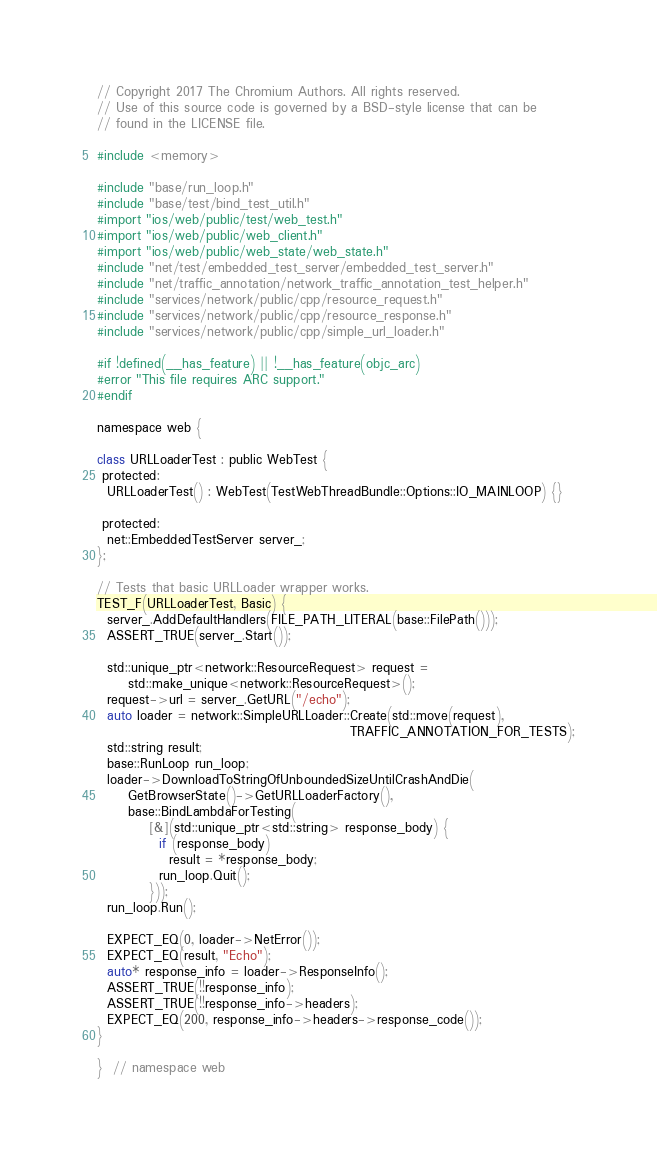<code> <loc_0><loc_0><loc_500><loc_500><_ObjectiveC_>// Copyright 2017 The Chromium Authors. All rights reserved.
// Use of this source code is governed by a BSD-style license that can be
// found in the LICENSE file.

#include <memory>

#include "base/run_loop.h"
#include "base/test/bind_test_util.h"
#import "ios/web/public/test/web_test.h"
#import "ios/web/public/web_client.h"
#import "ios/web/public/web_state/web_state.h"
#include "net/test/embedded_test_server/embedded_test_server.h"
#include "net/traffic_annotation/network_traffic_annotation_test_helper.h"
#include "services/network/public/cpp/resource_request.h"
#include "services/network/public/cpp/resource_response.h"
#include "services/network/public/cpp/simple_url_loader.h"

#if !defined(__has_feature) || !__has_feature(objc_arc)
#error "This file requires ARC support."
#endif

namespace web {

class URLLoaderTest : public WebTest {
 protected:
  URLLoaderTest() : WebTest(TestWebThreadBundle::Options::IO_MAINLOOP) {}

 protected:
  net::EmbeddedTestServer server_;
};

// Tests that basic URLLoader wrapper works.
TEST_F(URLLoaderTest, Basic) {
  server_.AddDefaultHandlers(FILE_PATH_LITERAL(base::FilePath()));
  ASSERT_TRUE(server_.Start());

  std::unique_ptr<network::ResourceRequest> request =
      std::make_unique<network::ResourceRequest>();
  request->url = server_.GetURL("/echo");
  auto loader = network::SimpleURLLoader::Create(std::move(request),
                                                 TRAFFIC_ANNOTATION_FOR_TESTS);
  std::string result;
  base::RunLoop run_loop;
  loader->DownloadToStringOfUnboundedSizeUntilCrashAndDie(
      GetBrowserState()->GetURLLoaderFactory(),
      base::BindLambdaForTesting(
          [&](std::unique_ptr<std::string> response_body) {
            if (response_body)
              result = *response_body;
            run_loop.Quit();
          }));
  run_loop.Run();

  EXPECT_EQ(0, loader->NetError());
  EXPECT_EQ(result, "Echo");
  auto* response_info = loader->ResponseInfo();
  ASSERT_TRUE(!!response_info);
  ASSERT_TRUE(!!response_info->headers);
  EXPECT_EQ(200, response_info->headers->response_code());
}

}  // namespace web
</code> 